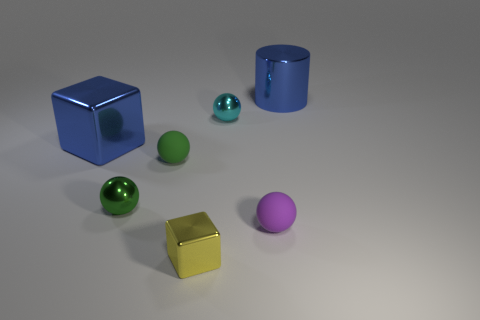Which objects in the image might indicate a size relationship or give a sense of scale? The sphere and cube close to the center of the image provide a sense of scale. They are both smaller than the nearby blue cylinder and gold cube, suggesting a range of sizes within the scene.  Is there any indication of light source or shadows in the image? Yes, the lighting suggests a light source above the objects to the left, casting subtle shadows towards the right of the frame. The brightest reflections are on the top surfaces of the objects, helping to define their three-dimensional shape. 